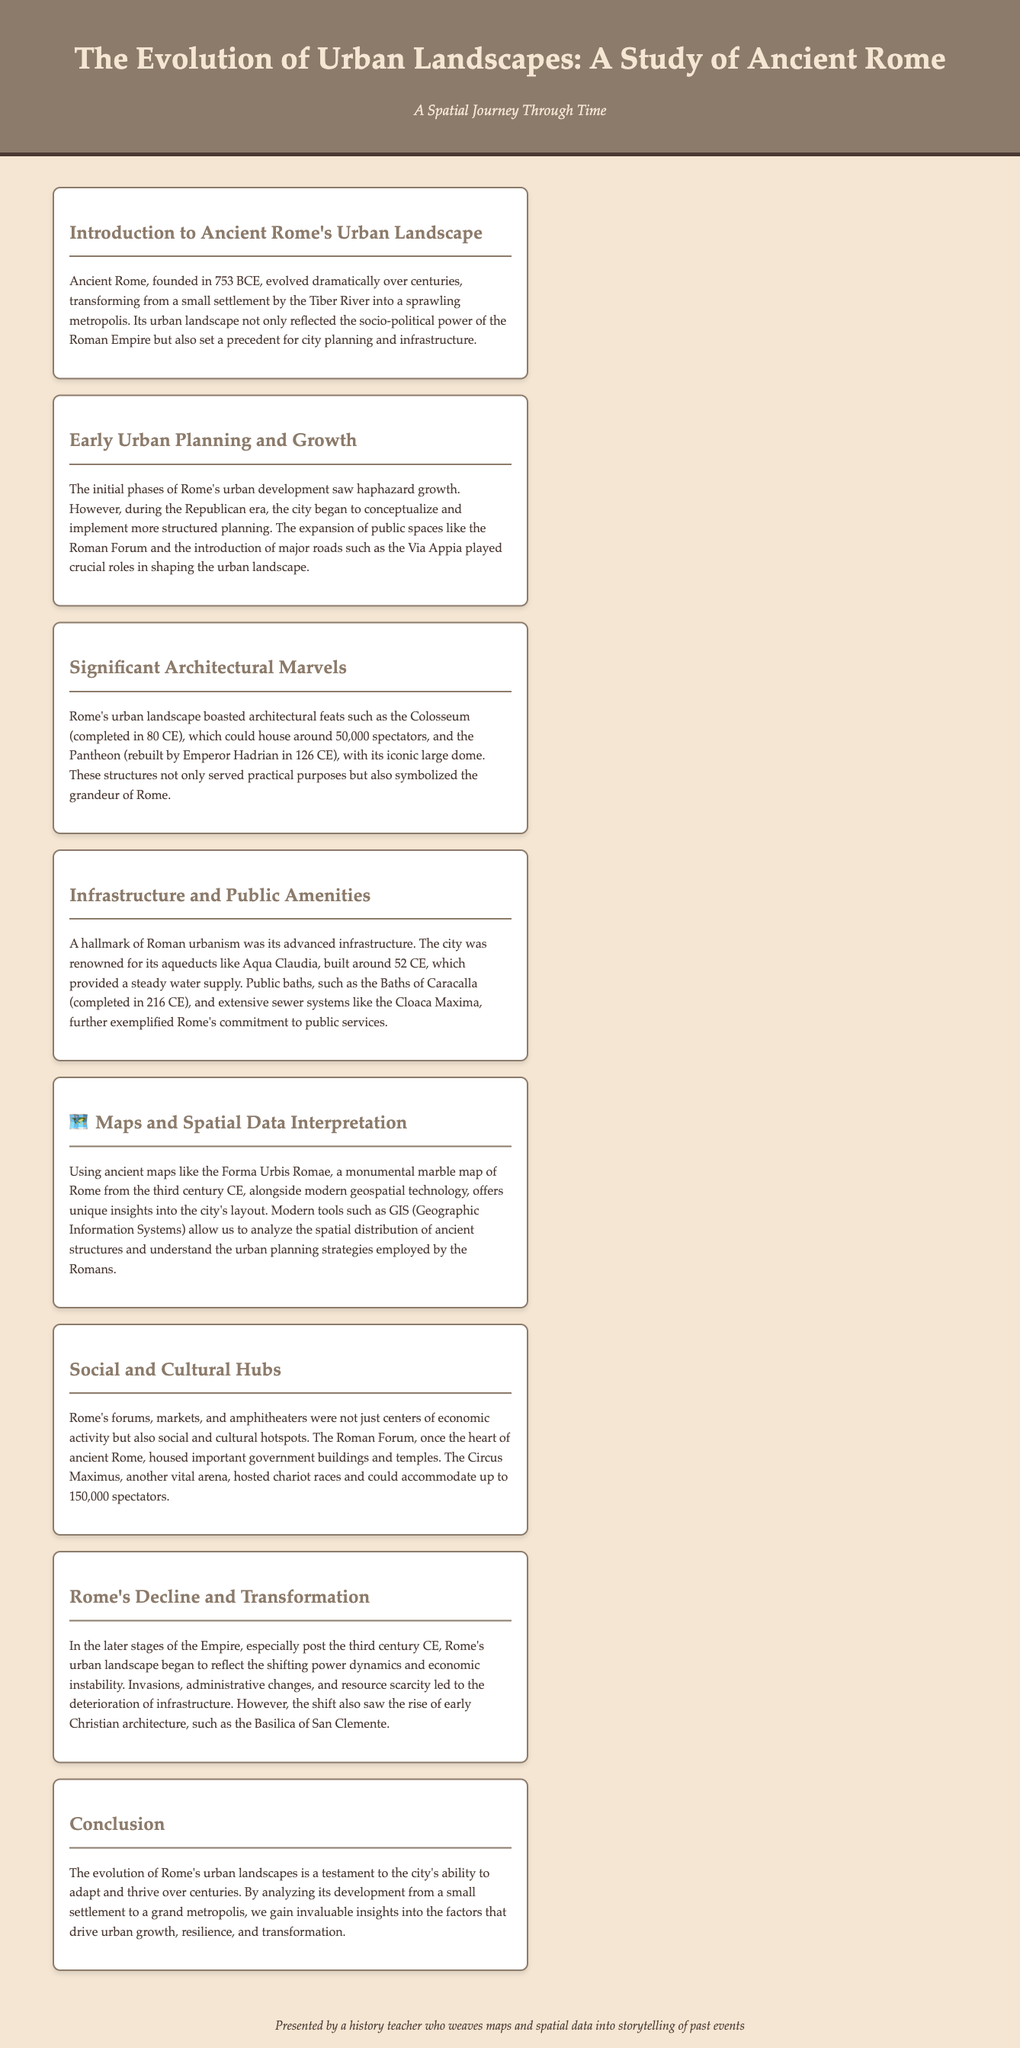What year was Ancient Rome founded? The document states that Ancient Rome was founded in 753 BCE.
Answer: 753 BCE What major road was introduced during the Republican era? The Via Appia is mentioned as a major road introduced during the Republican era.
Answer: Via Appia Which structure could house around 50,000 spectators? The Colosseum is noted for its capacity to house around 50,000 spectators.
Answer: Colosseum What aqueduct was built around 52 CE? Aqua Claudia is identified as an aqueduct built around 52 CE.
Answer: Aqua Claudia What was the heart of Ancient Rome? The Roman Forum is referred to as the heart of Ancient Rome.
Answer: Roman Forum Which architectural style rose in early Christian architecture? The document mentions that the Basilica of San Clemente represents early Christian architecture.
Answer: Basilica of San Clemente How did Rome's urban landscape change after the third century CE? The document discusses the deterioration of infrastructure and the rise of early Christian architecture after the third century CE.
Answer: Deterioration of infrastructure What technique allows modern analysis of Ancient Rome's layout? Geographic Information Systems (GIS) is mentioned as a technique for analyzing the layout of Ancient Rome.
Answer: Geographic Information Systems (GIS) What type of document is this study? The transcript presents a study of Ancient Rome's urban landscapes.
Answer: Study 